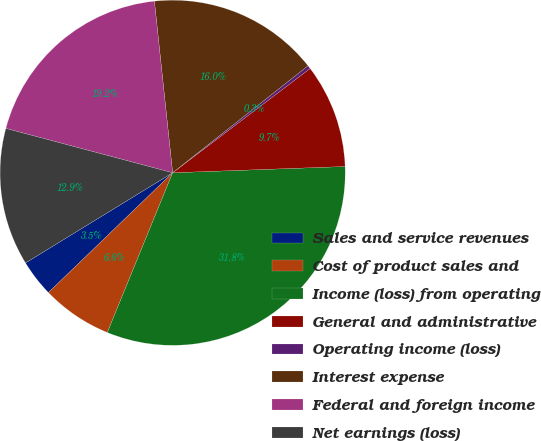Convert chart. <chart><loc_0><loc_0><loc_500><loc_500><pie_chart><fcel>Sales and service revenues<fcel>Cost of product sales and<fcel>Income (loss) from operating<fcel>General and administrative<fcel>Operating income (loss)<fcel>Interest expense<fcel>Federal and foreign income<fcel>Net earnings (loss)<nl><fcel>3.46%<fcel>6.61%<fcel>31.76%<fcel>9.75%<fcel>0.32%<fcel>16.04%<fcel>19.18%<fcel>12.89%<nl></chart> 